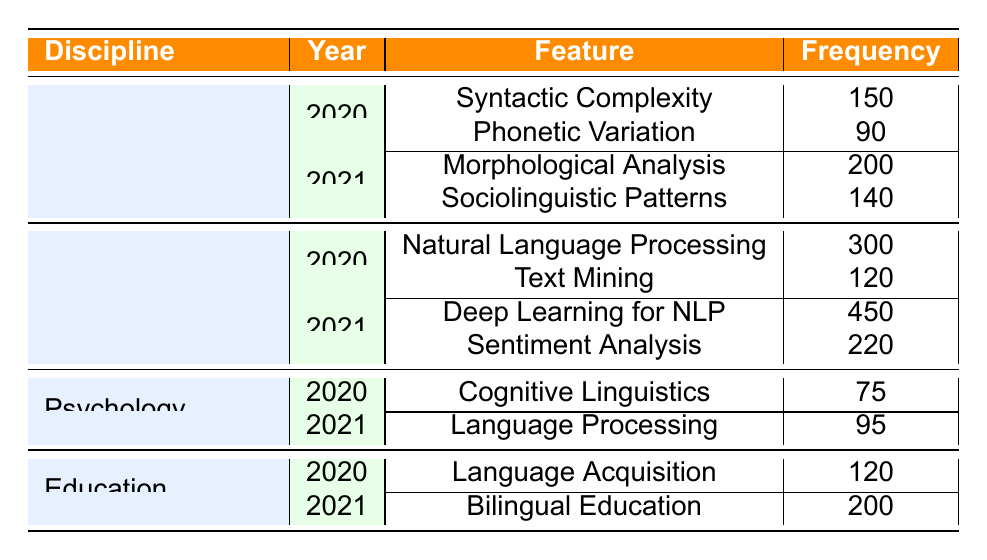What is the frequency of Syntactic Complexity in Linguistics for the year 2020? From the table, under the Linguistics discipline and for the year 2020, the entry for Syntactic Complexity shows a frequency of 150.
Answer: 150 Which feature had the highest frequency in Computer Science in 2021? In 2021, the table lists two features for Computer Science: Deep Learning for NLP with a frequency of 450 and Sentiment Analysis with a frequency of 220. The highest frequency is therefore 450 for Deep Learning for NLP.
Answer: 450 What is the total frequency of linguistic features for the discipline of Psychology? For Psychology, the frequencies are 75 for Cognitive Linguistics in 2020 and 95 for Language Processing in 2021. Adding these gives: 75 + 95 = 170.
Answer: 170 Does the discipline of Education have a feature frequency greater than 100 in 2020? Referring to the table, Education has one feature listed for 2020, Language Acquisition, with a frequency of 120. Since 120 is greater than 100, the answer is yes.
Answer: Yes Which discipline had the highest increase in frequency from 2020 to 2021? First, we must calculate the total frequency for each discipline in both years. For Linguistics: 2020 (150+90=240), 2021 (200+140=340), increase = 100. For Computer Science: 2020 (300+120=420), 2021 (450+220=670), increase = 250. For Psychology: 2020 (75), 2021 (95), increase = 20. For Education: 2020 (120), 2021 (200), increase = 80. The highest increase is therefore for Computer Science with 250.
Answer: Computer Science What is the average frequency of linguistic features in Linguistics for the year 2021? In 2021 for Linguistics, there are two features: Morphological Analysis (200) and Sociolinguistic Patterns (140). The sum is: 200 + 140 = 340. Since there are 2 features, the average is 340 / 2 = 170.
Answer: 170 